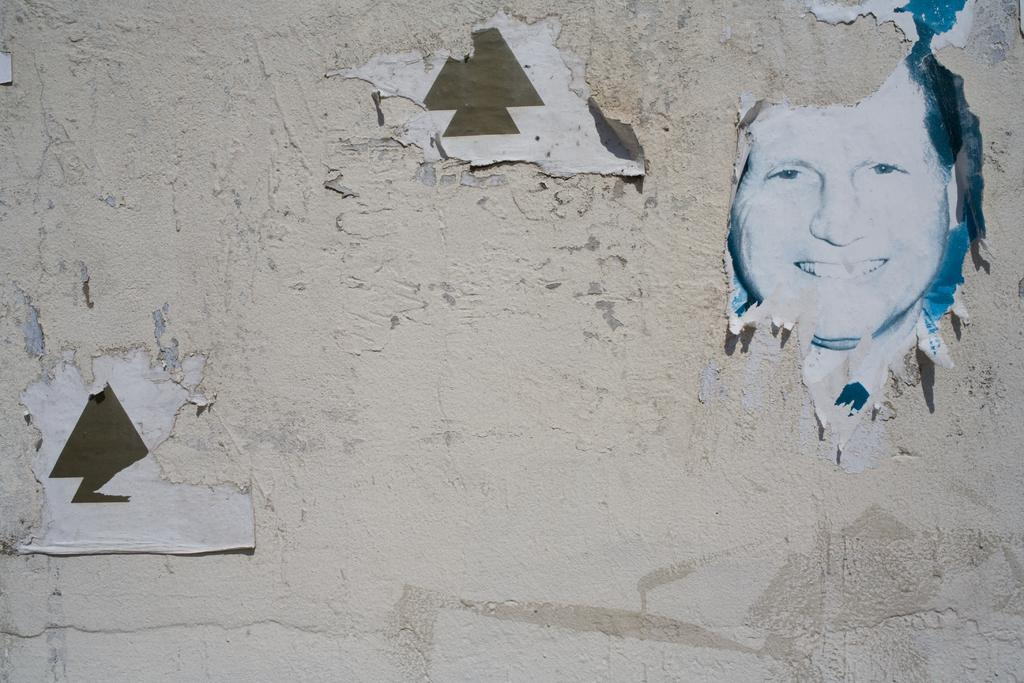What is present on the wall in the image? There is a half poster torn of a person on the wall. Can you describe the condition of the poster? The poster is torn and only half of it is visible in the image. What degree does the person in the poster have? There is no information about the person's degree in the image, as it only shows a torn half of a poster. 